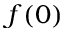<formula> <loc_0><loc_0><loc_500><loc_500>f ( 0 )</formula> 